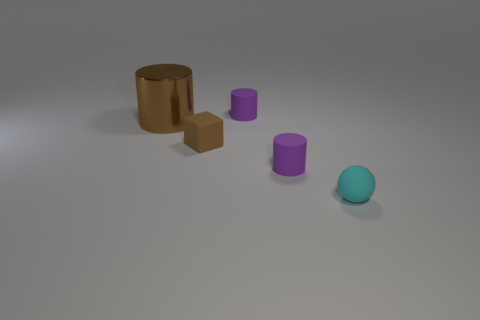Add 1 tiny gray metallic cylinders. How many objects exist? 6 Subtract all spheres. How many objects are left? 4 Add 3 brown cylinders. How many brown cylinders exist? 4 Subtract 0 red spheres. How many objects are left? 5 Subtract all big things. Subtract all big objects. How many objects are left? 3 Add 1 large brown things. How many large brown things are left? 2 